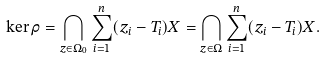Convert formula to latex. <formula><loc_0><loc_0><loc_500><loc_500>\ker \rho = \bigcap _ { z \in \Omega _ { 0 } } \sum _ { i = 1 } ^ { n } ( z _ { i } - T _ { i } ) X = \bigcap _ { z \in \Omega } \sum _ { i = 1 } ^ { n } ( z _ { i } - T _ { i } ) X .</formula> 